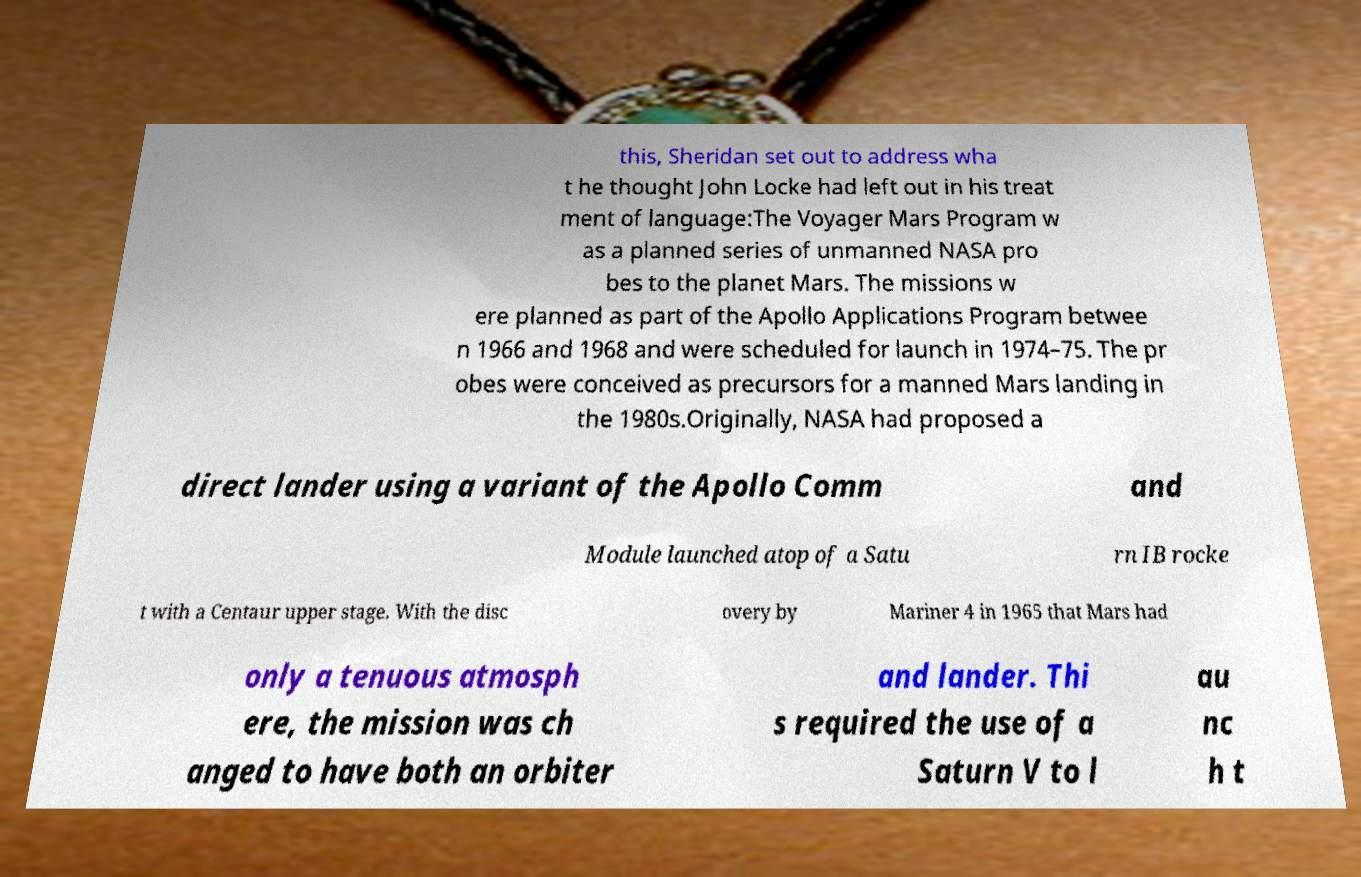What messages or text are displayed in this image? I need them in a readable, typed format. this, Sheridan set out to address wha t he thought John Locke had left out in his treat ment of language:The Voyager Mars Program w as a planned series of unmanned NASA pro bes to the planet Mars. The missions w ere planned as part of the Apollo Applications Program betwee n 1966 and 1968 and were scheduled for launch in 1974–75. The pr obes were conceived as precursors for a manned Mars landing in the 1980s.Originally, NASA had proposed a direct lander using a variant of the Apollo Comm and Module launched atop of a Satu rn IB rocke t with a Centaur upper stage. With the disc overy by Mariner 4 in 1965 that Mars had only a tenuous atmosph ere, the mission was ch anged to have both an orbiter and lander. Thi s required the use of a Saturn V to l au nc h t 